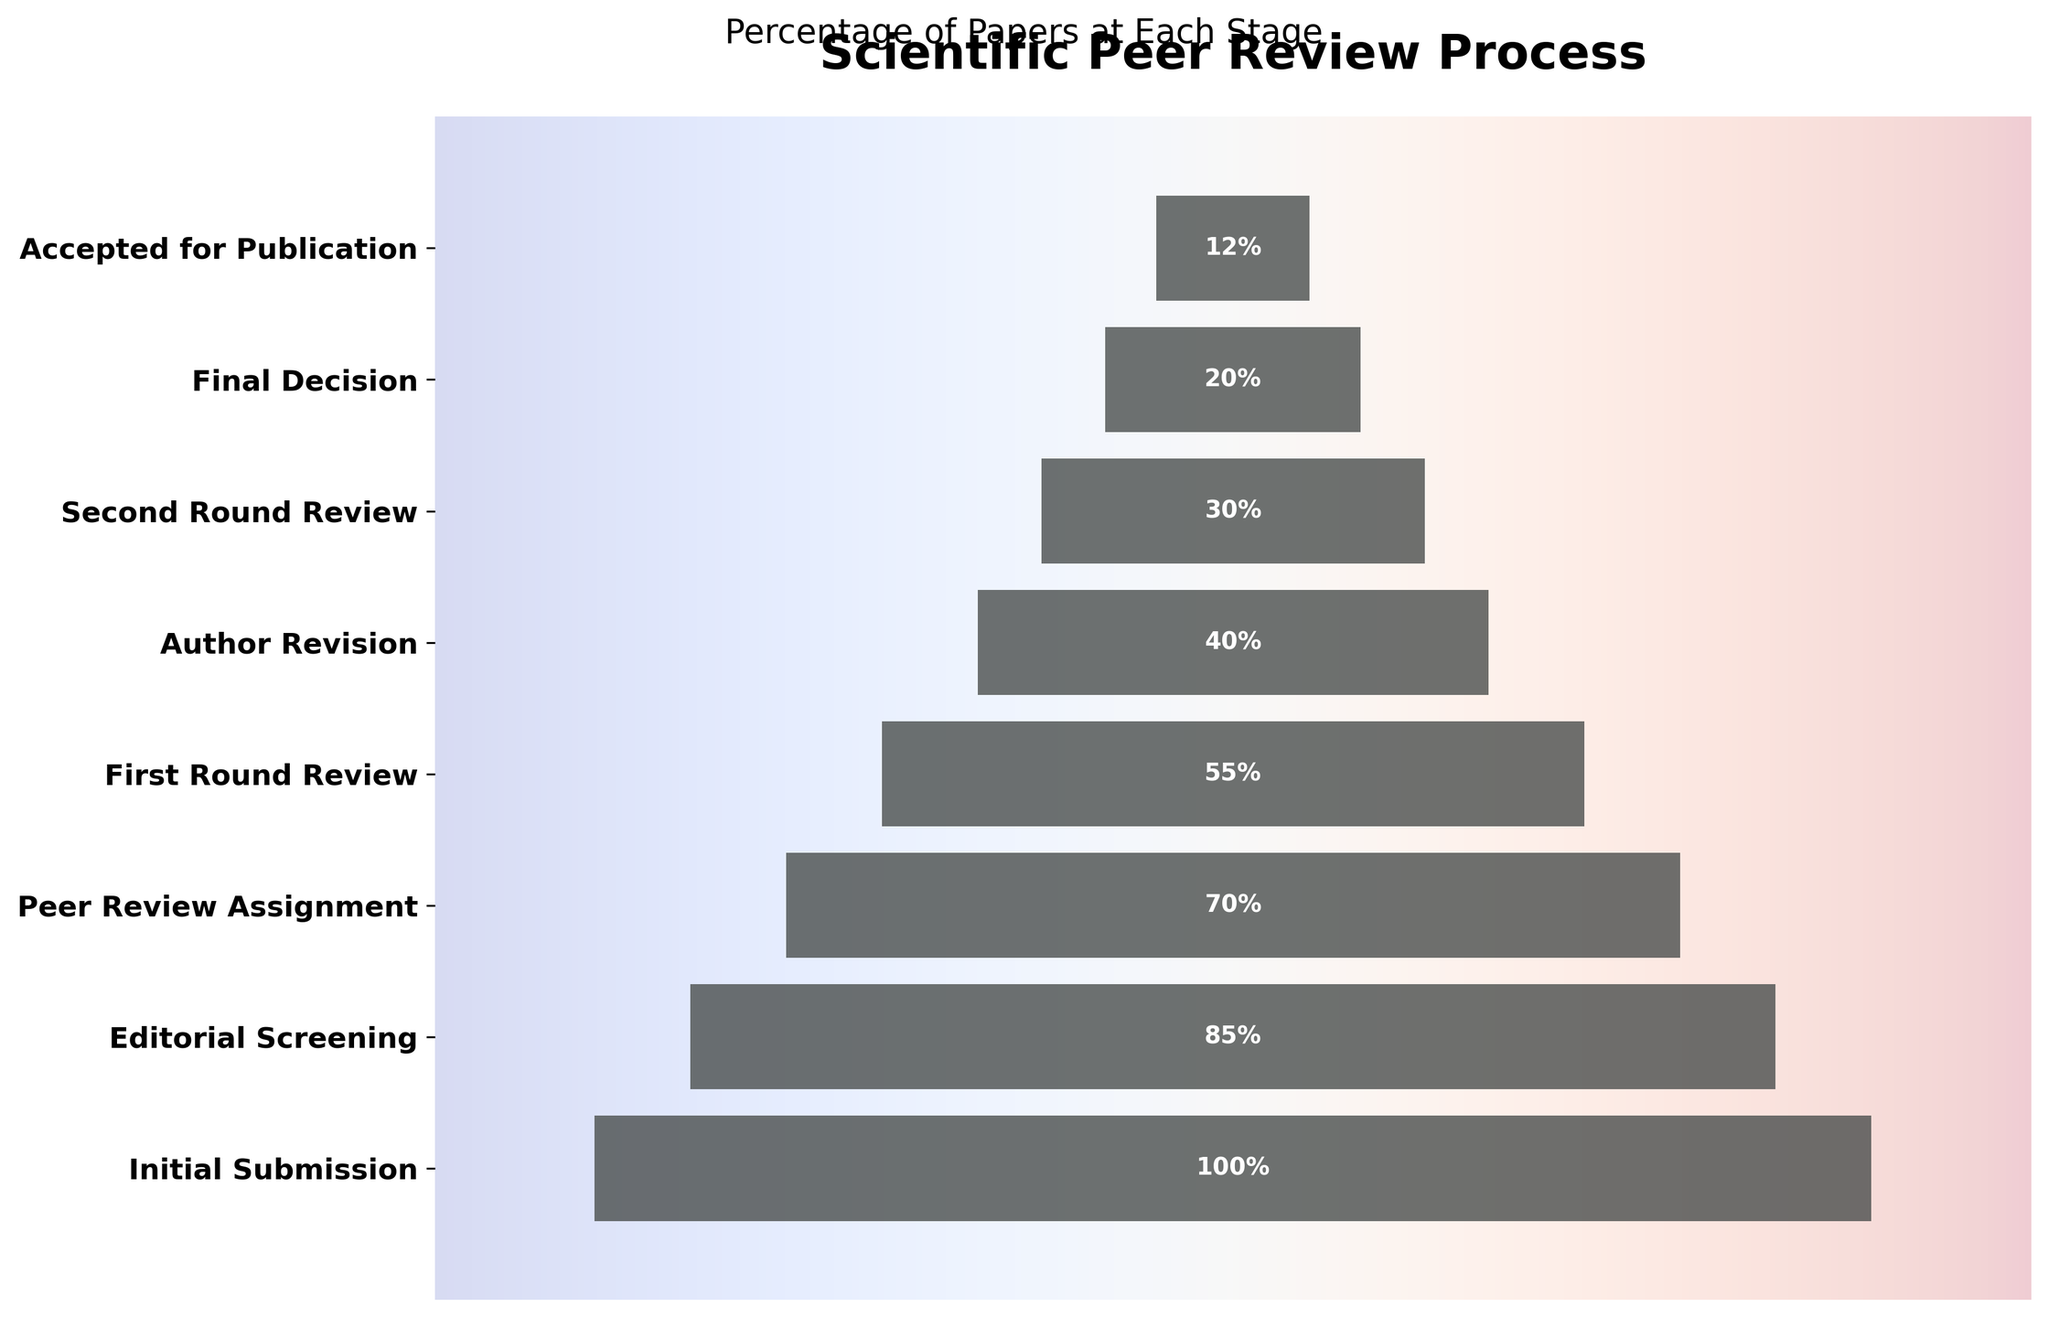What's the title of the figure? The title of the figure is written at the top of the chart. The title reads "Scientific Peer Review Process".
Answer: Scientific Peer Review Process How many stages are shown in this funnel chart? By counting the number of horizontal bars in the chart, we can see there are 8 stages represented.
Answer: 8 What is the percentage of papers accepted for publication? The chart has percentages labeled on each stage. Locate the "Accepted for Publication" bar and see it is labeled with 12%.
Answer: 12% Which stage has the highest percentage drop compared to the previous stage? Calculate the difference in percentages between each consecutive stage and find the maximum value. The biggest drop is between "Initial Submission" (100%) and "Editorial Screening" (85%), which is a 15% drop.
Answer: Between Initial Submission and Editorial Screening How many percentage points drop from the First Round Review to the Second Round Review? The chart shows 55% for First Round Review and 30% for Second Round Review. The drop is 55% - 30% = 25%.
Answer: 25% What percentage of the papers reach the Author Revision stage? Locate the "Author Revision" stage on the chart and see it is labeled with 40%.
Answer: 40% What stage comes immediately before the "Final Decision" stage, and what is its percentage? Trace the sequence of stages. The stage just before "Final Decision" is "Second Round Review," and it is labeled with 30%.
Answer: Second Round Review, 30% What is the percentage difference between the "Peer Review Assignment" stage and the "Accepted for Publication" stage? The "Peer Review Assignment" stage is at 70%, and the "Accepted for Publication" stage is at 12%. The difference is 70% - 12% = 58%.
Answer: 58% By what percentage does the number of papers reduce from the initial submission to final acceptance? The Initial Submission is 100%, and the Accepted for Publication is 12%. The reduction in percentage is calculated by 100% - 12% = 88%.
Answer: 88% Is the percentage of papers at the "Editorial Screening" stage higher or lower than half of those at the "First Round Review" stage? The percentage at "Editorial Screening" is 85%. Half of the percentage at the "First Round Review" is 55% / 2 = 27.5%. 85% is higher than 27.5%.
Answer: Higher 